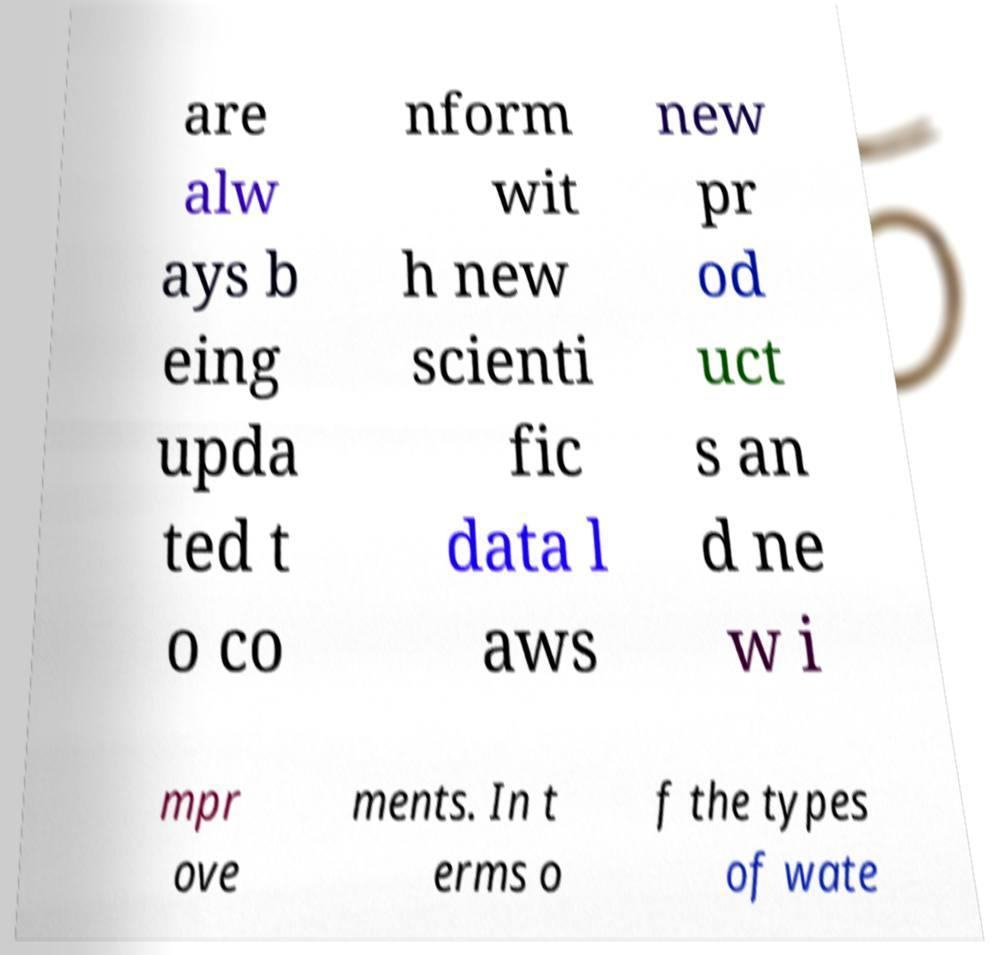Can you read and provide the text displayed in the image?This photo seems to have some interesting text. Can you extract and type it out for me? are alw ays b eing upda ted t o co nform wit h new scienti fic data l aws new pr od uct s an d ne w i mpr ove ments. In t erms o f the types of wate 